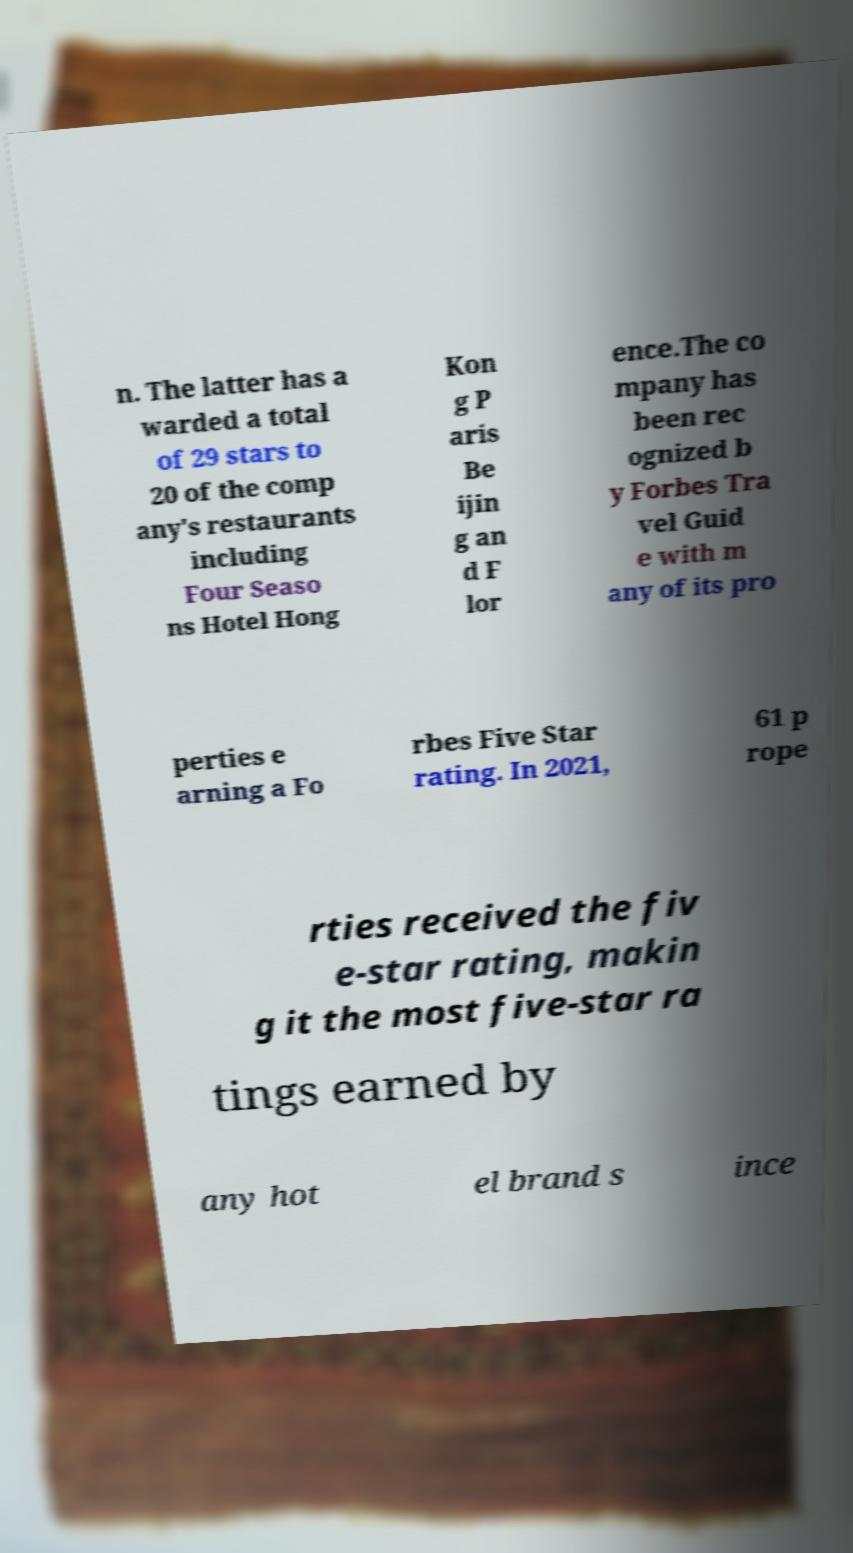Please read and relay the text visible in this image. What does it say? n. The latter has a warded a total of 29 stars to 20 of the comp any's restaurants including Four Seaso ns Hotel Hong Kon g P aris Be ijin g an d F lor ence.The co mpany has been rec ognized b y Forbes Tra vel Guid e with m any of its pro perties e arning a Fo rbes Five Star rating. In 2021, 61 p rope rties received the fiv e-star rating, makin g it the most five-star ra tings earned by any hot el brand s ince 